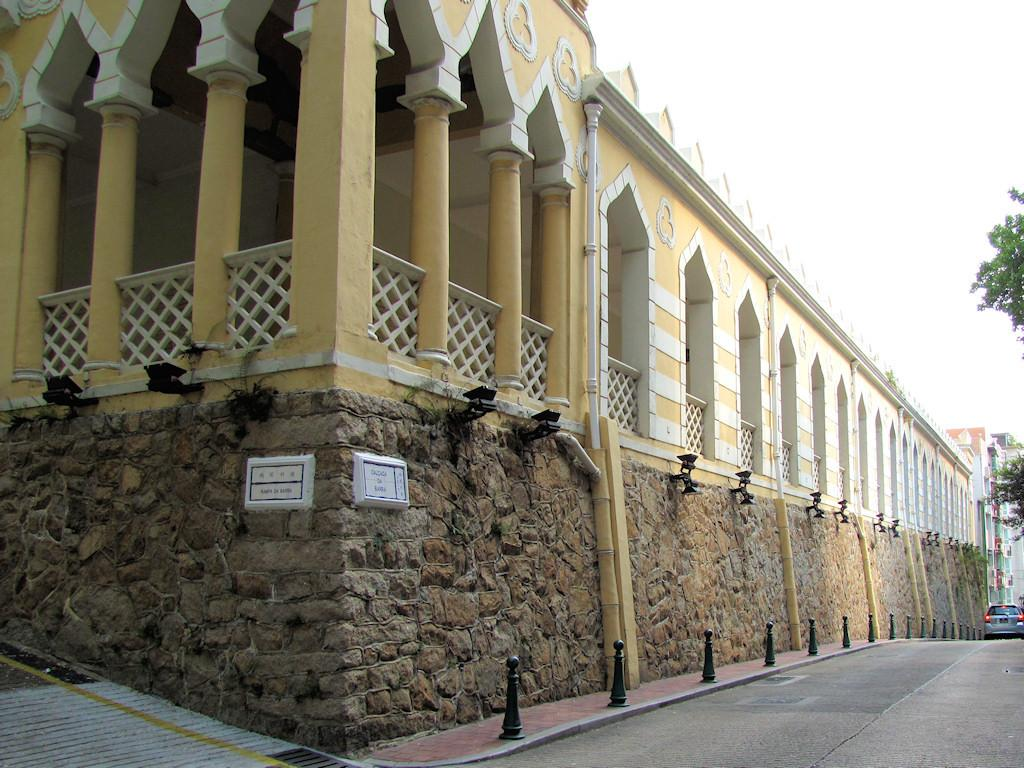What type of structure is present in the image? There is a building in the image. What feature can be seen on the building's wall? The building has lights attached to its wall. What else is visible in the image besides the building? There is a vehicle and trees in the image. Are there any other structures in the image? Yes, there are other buildings in the image. What type of oatmeal is being served in the image? There is no oatmeal present in the image. How many rabbits can be seen playing near the trees in the image? There are no rabbits present in the image. 